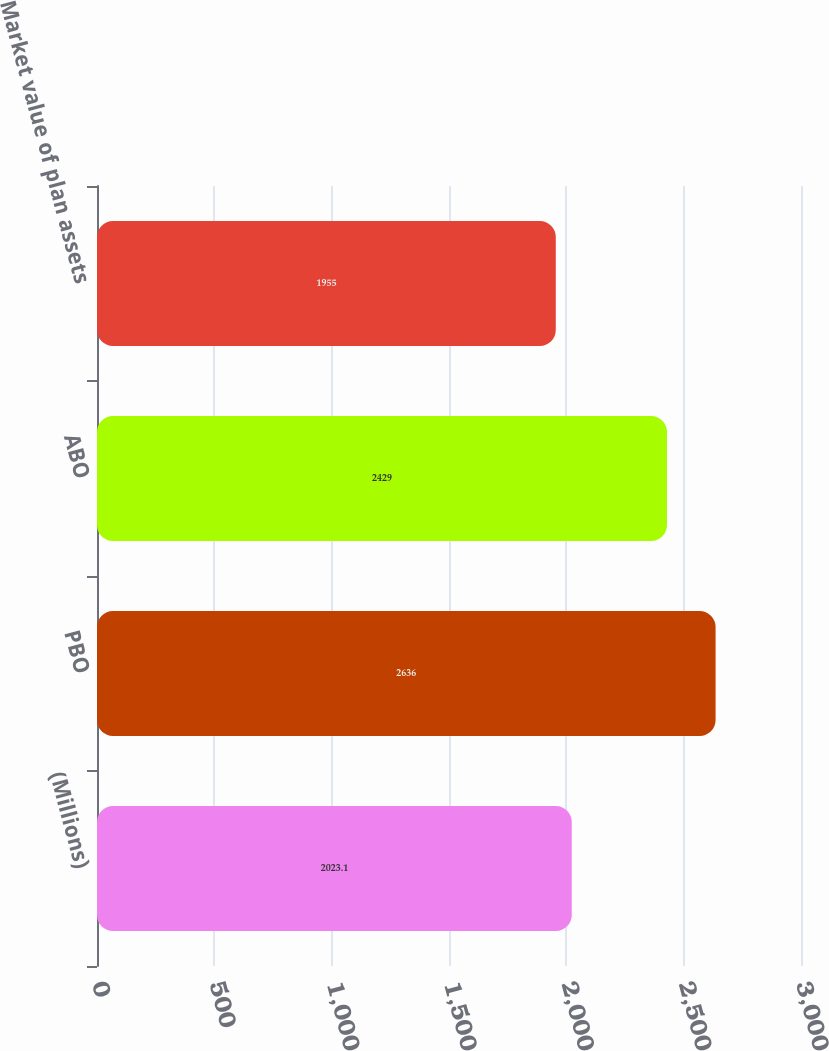Convert chart. <chart><loc_0><loc_0><loc_500><loc_500><bar_chart><fcel>(Millions)<fcel>PBO<fcel>ABO<fcel>Market value of plan assets<nl><fcel>2023.1<fcel>2636<fcel>2429<fcel>1955<nl></chart> 